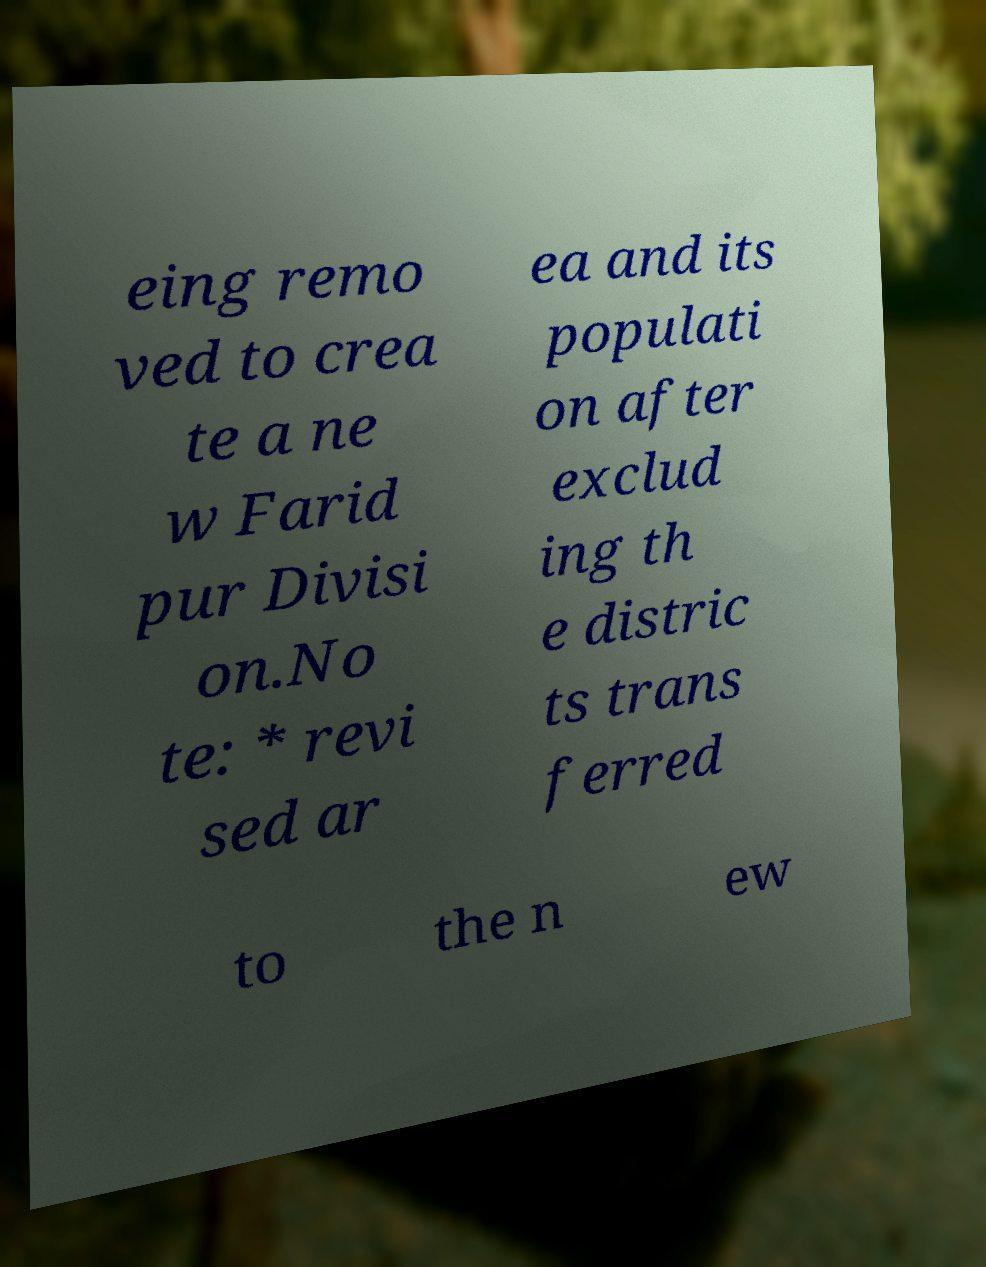Please identify and transcribe the text found in this image. eing remo ved to crea te a ne w Farid pur Divisi on.No te: * revi sed ar ea and its populati on after exclud ing th e distric ts trans ferred to the n ew 